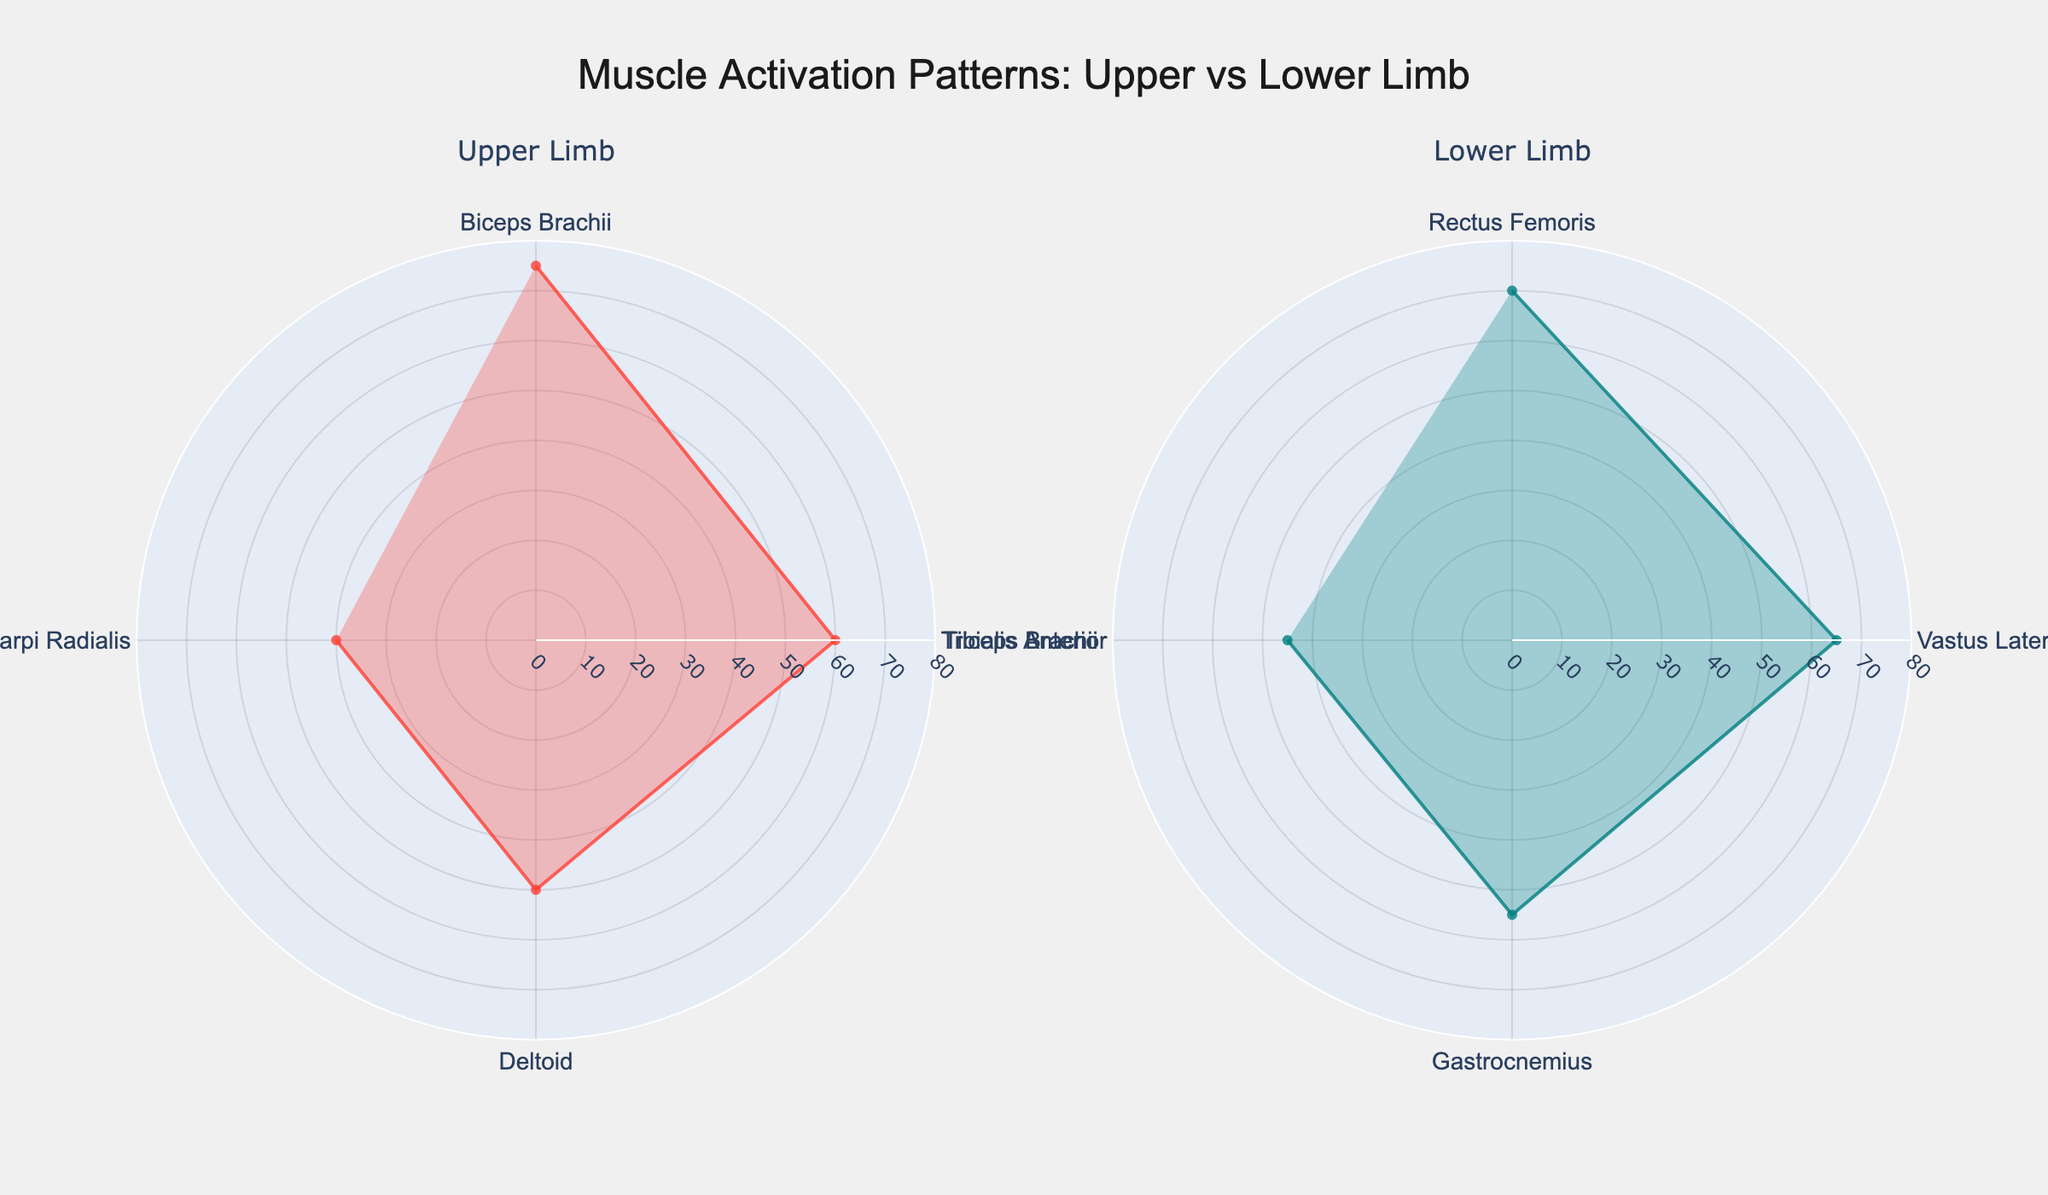Which group has the highest muscle activation level? By examining the radar chart, we can observe the radial distances representing muscle activation levels. The highest value in the upper limb group is 75 for the Biceps Brachii, whereas the highest in the lower limb group is 70 for the Rectus Femoris. Thus, the upper limb has the highest activation level.
Answer: Upper Limb What is the average muscle activation level for the upper limb group? To find the average, sum the activation levels of Biceps Brachii (75), Triceps Brachii (60), Deltoid (50), and Extensor Carpi Radialis (40). The sum is 225. Divide by 4 (number of muscles), giving us an average of 56.25.
Answer: 56.25 Which muscle has the lowest activation level in the lower limb group? By looking at the radar chart for the lower limb, the lowest radial distance corresponds to the Tibialis Anterior with an activation level of 45.
Answer: Tibialis Anterior Compare the activation levels of Gastrocnemius in the lower limb and Deltoid in the upper limb. Which is higher? From the radar chart, the activation level for Gastrocnemius is 55, while Deltoid is 50. Thus, Gastrocnemius has a higher activation level than Deltoid.
Answer: Gastrocnemius Which muscles have similar activation levels in both groups? Examining the radar charts, we see that the Triceps Brachii (60) in the upper limb and Vastus Lateralis (65) in the lower limb have relatively close activation levels.
Answer: Triceps Brachii and Vastus Lateralis What is the combined activation level of Extensor Carpi Radialis and Tibialis Anterior? The activation levels of Extensor Carpi Radialis (40) and Tibialis Anterior (45) add up to 85.
Answer: 85 Is the muscle activation level of Biceps Brachii greater than Rectus Femoris? By comparing the radar charts, the Biceps Brachii has an activation level of 75, while Rectus Femoris has 70. Hence, Biceps Brachii has a higher activation level.
Answer: Yes What's the difference in activation levels between the muscle with the highest activation in the lower limb group and the lowest activation in the upper limb group? The highest activation in the lower limb is Rectus Femoris (70), and the lowest in the upper limb is Extensor Carpi Radialis (40). The difference is 70 - 40 = 30.
Answer: 30 